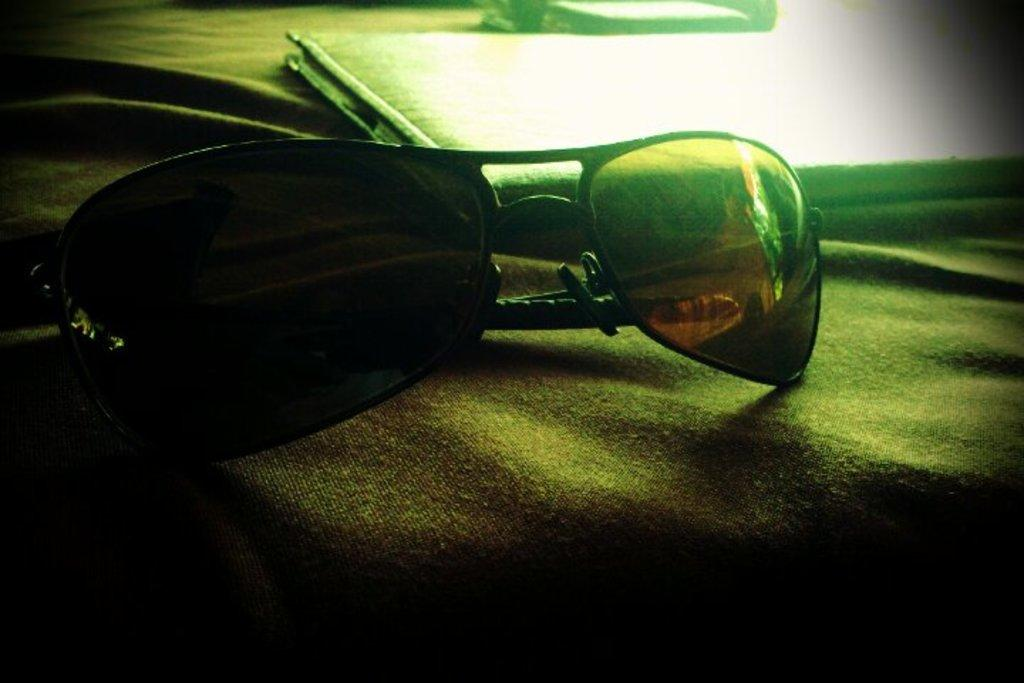What is placed on the cloth in the image? There are goggles on a cloth in the image. What can be seen behind the goggles in the image? There is an object that looks like a file behind the goggles in the image. What type of plate is being used by the farmer in the image? There is no farmer or plate present in the image; it only features goggles on a cloth and an object that looks like a file. 